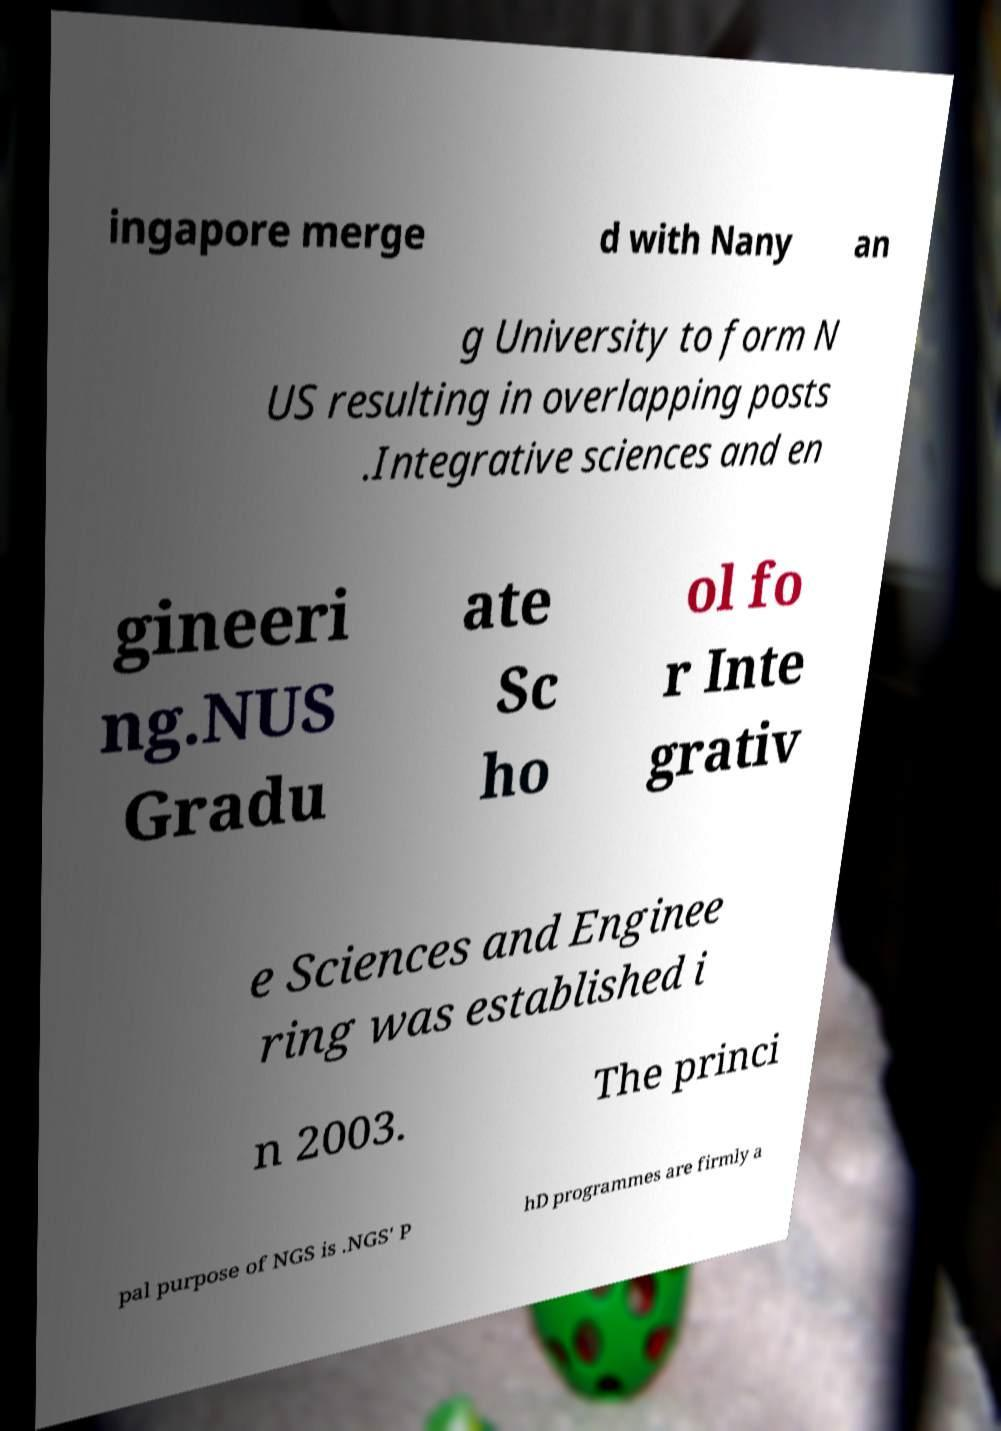Please read and relay the text visible in this image. What does it say? ingapore merge d with Nany an g University to form N US resulting in overlapping posts .Integrative sciences and en gineeri ng.NUS Gradu ate Sc ho ol fo r Inte grativ e Sciences and Enginee ring was established i n 2003. The princi pal purpose of NGS is .NGS' P hD programmes are firmly a 